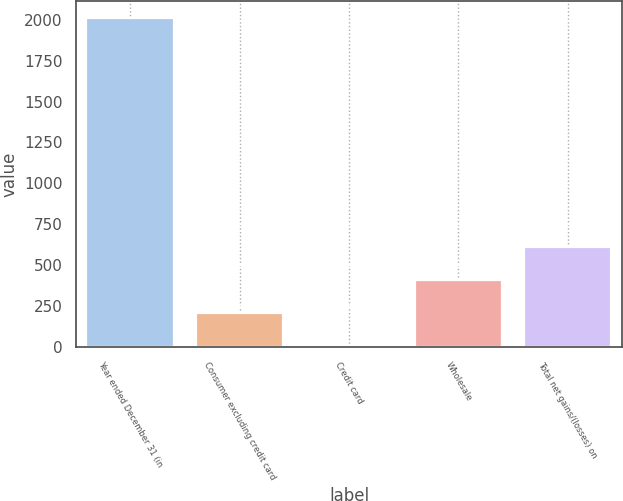Convert chart to OTSL. <chart><loc_0><loc_0><loc_500><loc_500><bar_chart><fcel>Year ended December 31 (in<fcel>Consumer excluding credit card<fcel>Credit card<fcel>Wholesale<fcel>Total net gains/(losses) on<nl><fcel>2012<fcel>209.3<fcel>9<fcel>409.6<fcel>609.9<nl></chart> 